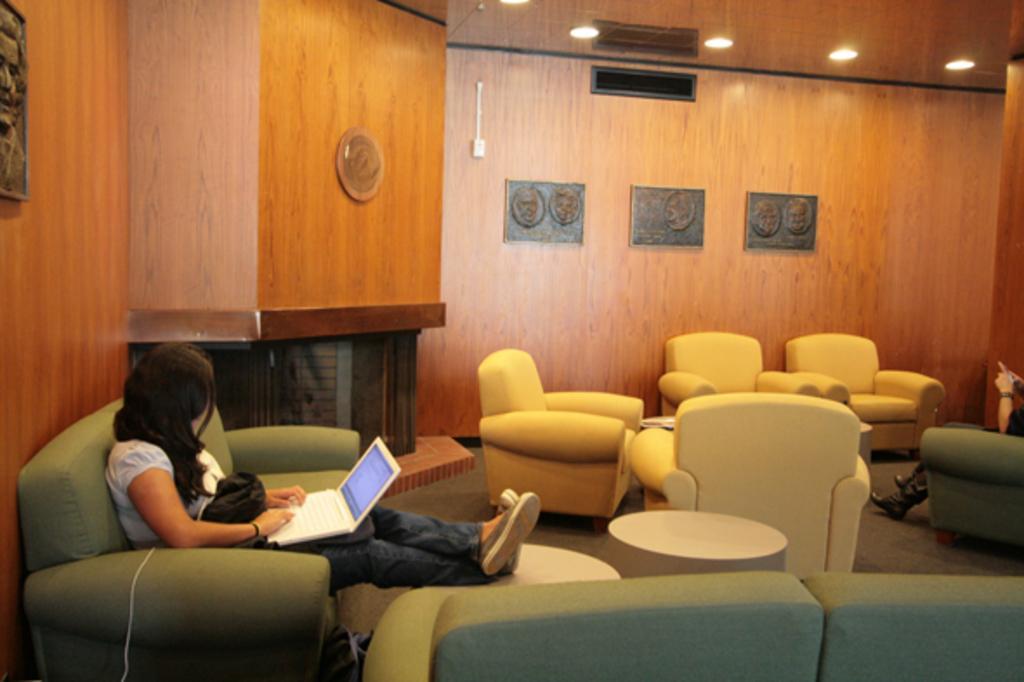Please provide a concise description of this image. This is the woman sitting on the couch. She is using laptop. These are the couches which are cream in color. These are the small tables. These are the frames attached to the wall. I think these are the ceiling lights attached to the rooftop. At the right corner of the image I can see another person sitting on the couch. 